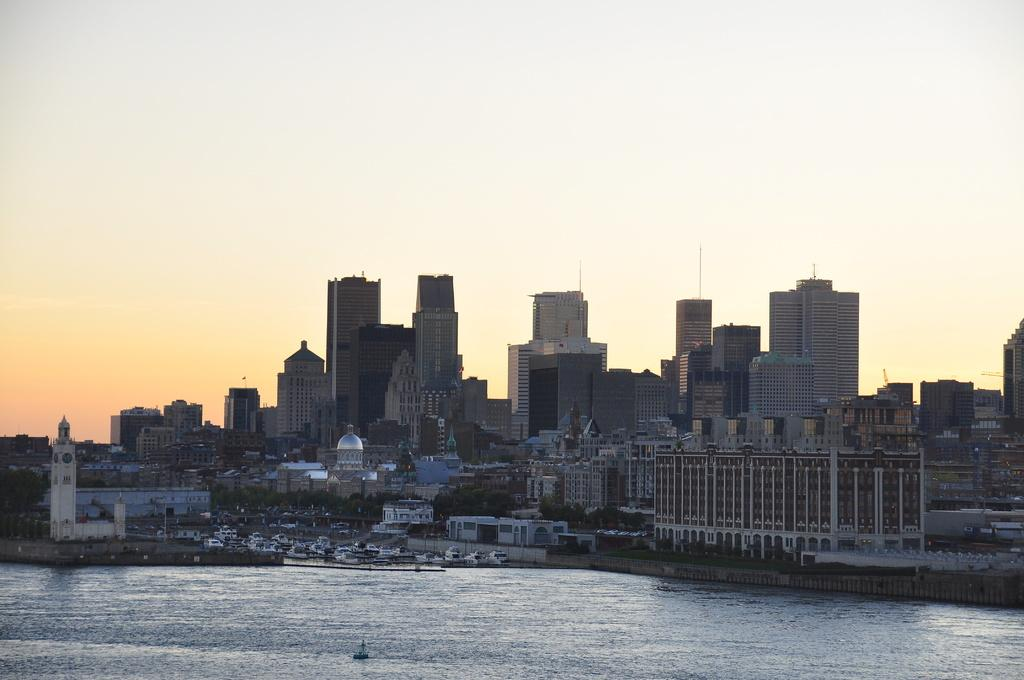What is the primary element in the image? There is water in the image. What can be seen in the background of the image? There are buildings with windows and trees in the background. What else is visible in the background? The sky is visible in the background. Can you see a lamp being kicked in the image? There is no lamp or kicking action present in the image. 